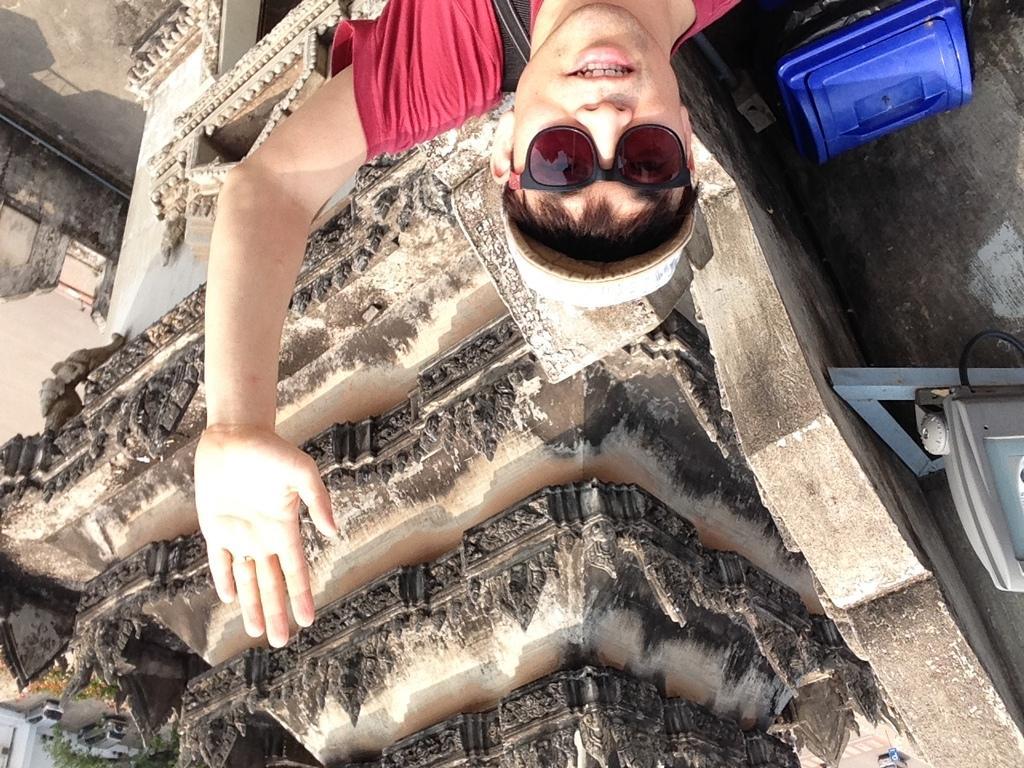Please provide a concise description of this image. In this image we can see a person wearing hat. On the right side of the image we can see a trash bin and a device placed on a metal frame. At the bottom of the image we can see group of vehicles parked on the ground, groups of trees and a building with windows. 